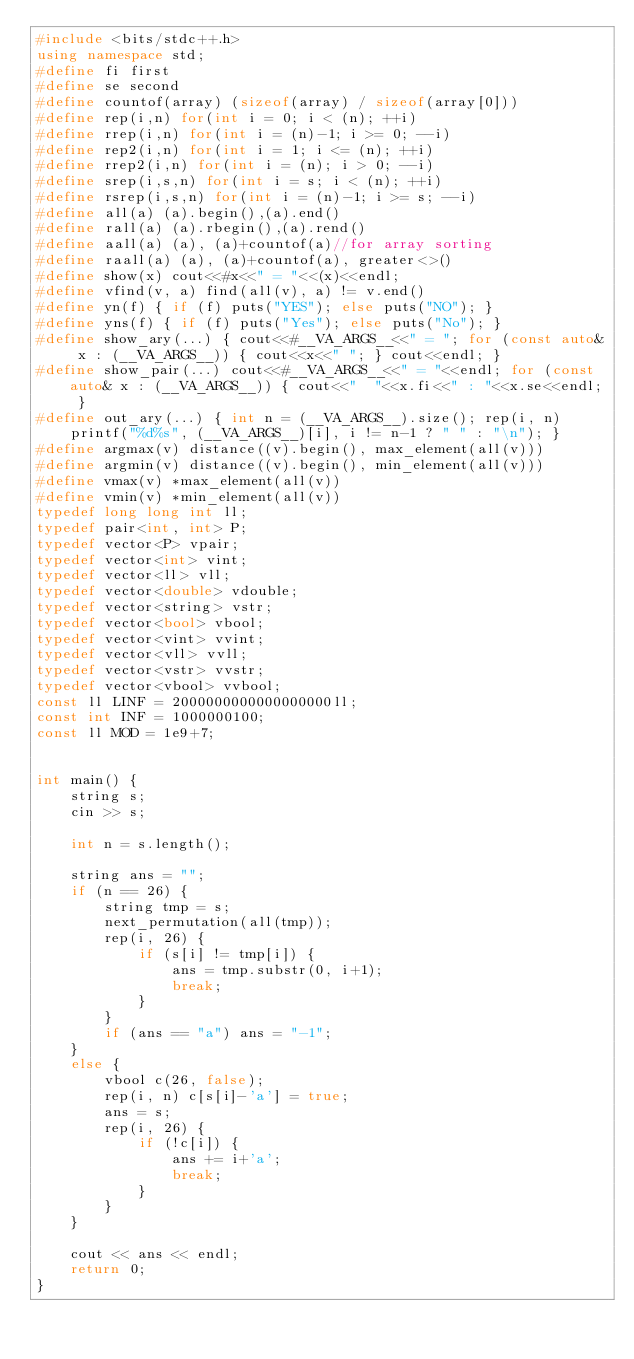<code> <loc_0><loc_0><loc_500><loc_500><_C++_>#include <bits/stdc++.h>
using namespace std;
#define fi first
#define se second
#define countof(array) (sizeof(array) / sizeof(array[0]))
#define rep(i,n) for(int i = 0; i < (n); ++i)
#define rrep(i,n) for(int i = (n)-1; i >= 0; --i)
#define rep2(i,n) for(int i = 1; i <= (n); ++i)
#define rrep2(i,n) for(int i = (n); i > 0; --i)
#define srep(i,s,n) for(int i = s; i < (n); ++i)
#define rsrep(i,s,n) for(int i = (n)-1; i >= s; --i)
#define all(a) (a).begin(),(a).end()
#define rall(a) (a).rbegin(),(a).rend()
#define aall(a) (a), (a)+countof(a)//for array sorting
#define raall(a) (a), (a)+countof(a), greater<>()
#define show(x) cout<<#x<<" = "<<(x)<<endl;
#define vfind(v, a) find(all(v), a) != v.end()
#define yn(f) { if (f) puts("YES"); else puts("NO"); }
#define yns(f) { if (f) puts("Yes"); else puts("No"); }
#define show_ary(...) { cout<<#__VA_ARGS__<<" = "; for (const auto& x : (__VA_ARGS__)) { cout<<x<<" "; } cout<<endl; }
#define show_pair(...) cout<<#__VA_ARGS__<<" = "<<endl; for (const auto& x : (__VA_ARGS__)) { cout<<"  "<<x.fi<<" : "<<x.se<<endl; }
#define out_ary(...) { int n = (__VA_ARGS__).size(); rep(i, n) printf("%d%s", (__VA_ARGS__)[i], i != n-1 ? " " : "\n"); }
#define argmax(v) distance((v).begin(), max_element(all(v)))
#define argmin(v) distance((v).begin(), min_element(all(v)))
#define vmax(v) *max_element(all(v))
#define vmin(v) *min_element(all(v))
typedef long long int ll;
typedef pair<int, int> P;
typedef vector<P> vpair;
typedef vector<int> vint;
typedef vector<ll> vll;
typedef vector<double> vdouble;
typedef vector<string> vstr;
typedef vector<bool> vbool;
typedef vector<vint> vvint;
typedef vector<vll> vvll;
typedef vector<vstr> vvstr;
typedef vector<vbool> vvbool;
const ll LINF = 2000000000000000000ll;
const int INF = 1000000100;
const ll MOD = 1e9+7;


int main() {
    string s;
    cin >> s;

    int n = s.length();

    string ans = "";
    if (n == 26) {
        string tmp = s;
        next_permutation(all(tmp));
        rep(i, 26) {
            if (s[i] != tmp[i]) {
                ans = tmp.substr(0, i+1);
                break;
            }
        }
        if (ans == "a") ans = "-1";
    }
    else {
        vbool c(26, false);
        rep(i, n) c[s[i]-'a'] = true;
        ans = s;
        rep(i, 26) {
            if (!c[i]) {
                ans += i+'a';
                break;
            }
        }
    }

    cout << ans << endl;
    return 0;
}</code> 